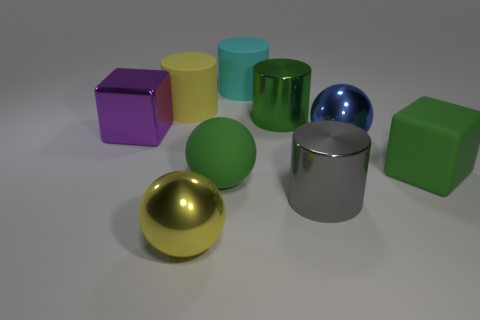How do the shapes of the objects in the image vary? The image displays a rich variety of geometric shapes. There are spherical objects like the golden and green spheres. Cubic forms are represented by the green cube and the purple cube, while cylindrical shapes are depicted with the cyan and silver cylinders. Each shape brings a distinctive form and contributes to the visual diversity of the scene. 